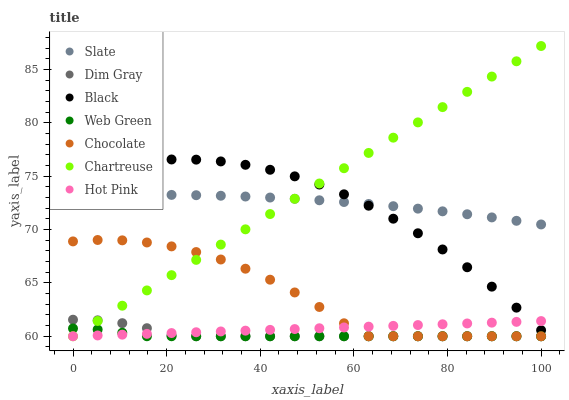Does Web Green have the minimum area under the curve?
Answer yes or no. Yes. Does Chartreuse have the maximum area under the curve?
Answer yes or no. Yes. Does Slate have the minimum area under the curve?
Answer yes or no. No. Does Slate have the maximum area under the curve?
Answer yes or no. No. Is Hot Pink the smoothest?
Answer yes or no. Yes. Is Chocolate the roughest?
Answer yes or no. Yes. Is Slate the smoothest?
Answer yes or no. No. Is Slate the roughest?
Answer yes or no. No. Does Dim Gray have the lowest value?
Answer yes or no. Yes. Does Slate have the lowest value?
Answer yes or no. No. Does Chartreuse have the highest value?
Answer yes or no. Yes. Does Slate have the highest value?
Answer yes or no. No. Is Chocolate less than Slate?
Answer yes or no. Yes. Is Slate greater than Hot Pink?
Answer yes or no. Yes. Does Chocolate intersect Chartreuse?
Answer yes or no. Yes. Is Chocolate less than Chartreuse?
Answer yes or no. No. Is Chocolate greater than Chartreuse?
Answer yes or no. No. Does Chocolate intersect Slate?
Answer yes or no. No. 